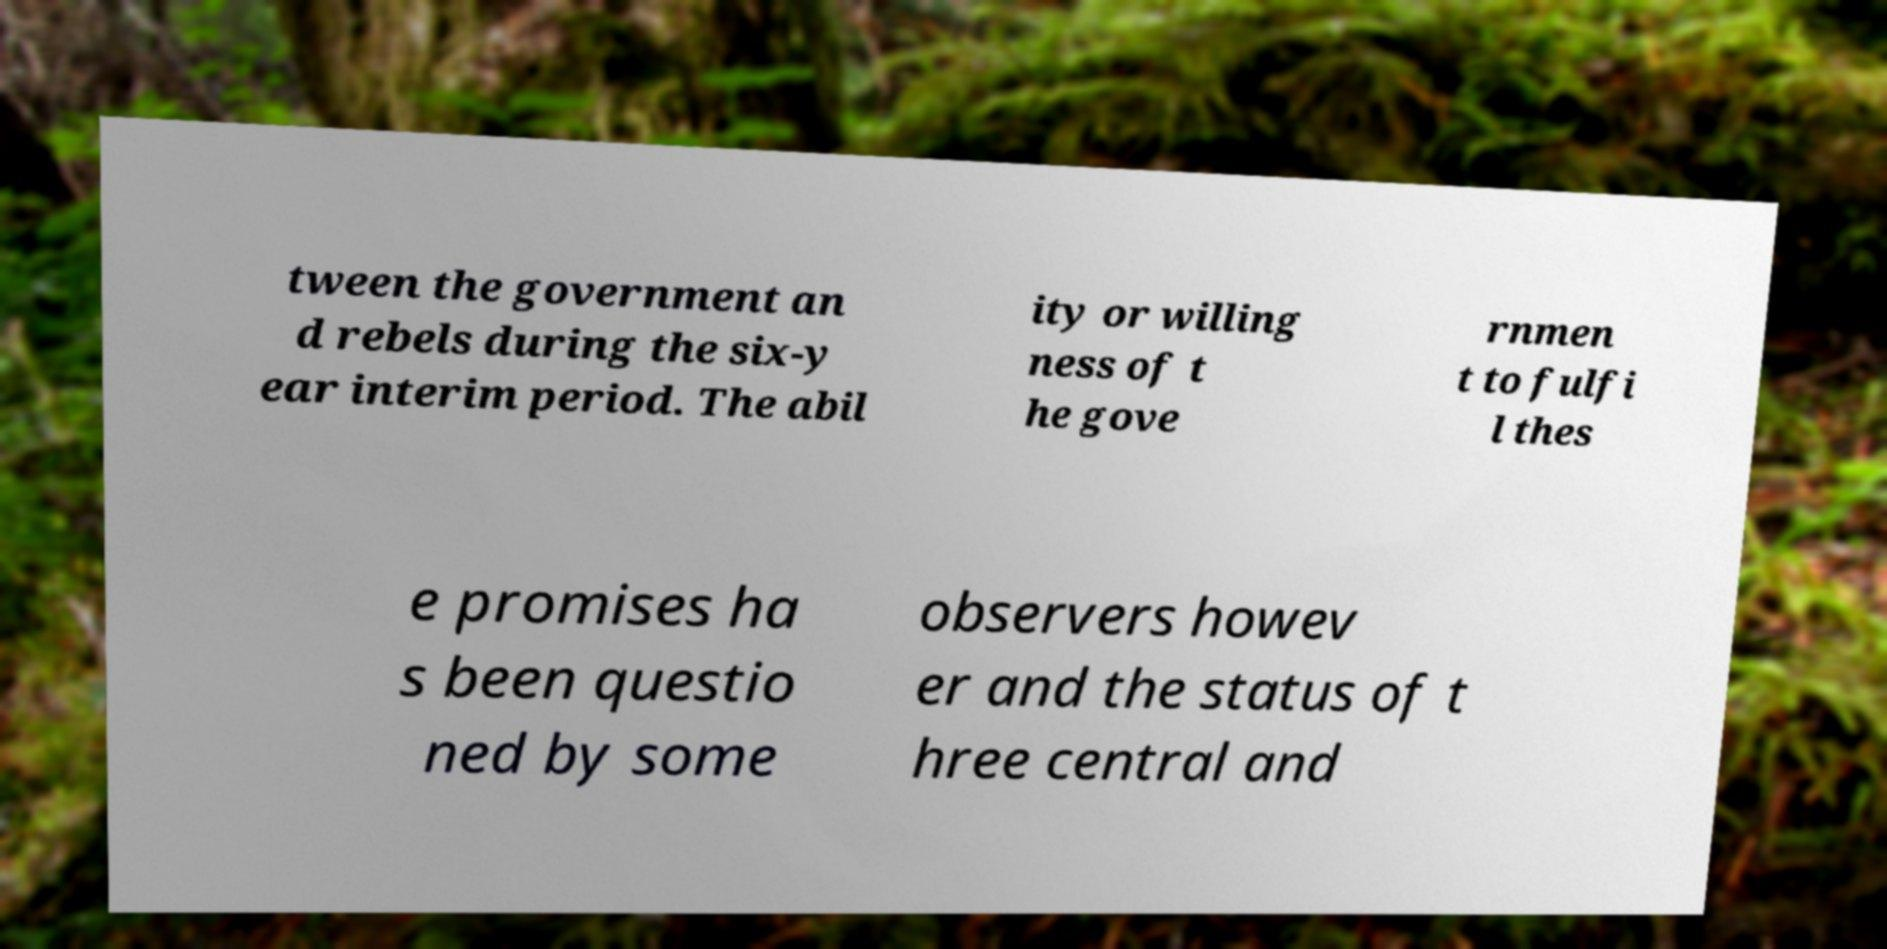Could you extract and type out the text from this image? tween the government an d rebels during the six-y ear interim period. The abil ity or willing ness of t he gove rnmen t to fulfi l thes e promises ha s been questio ned by some observers howev er and the status of t hree central and 